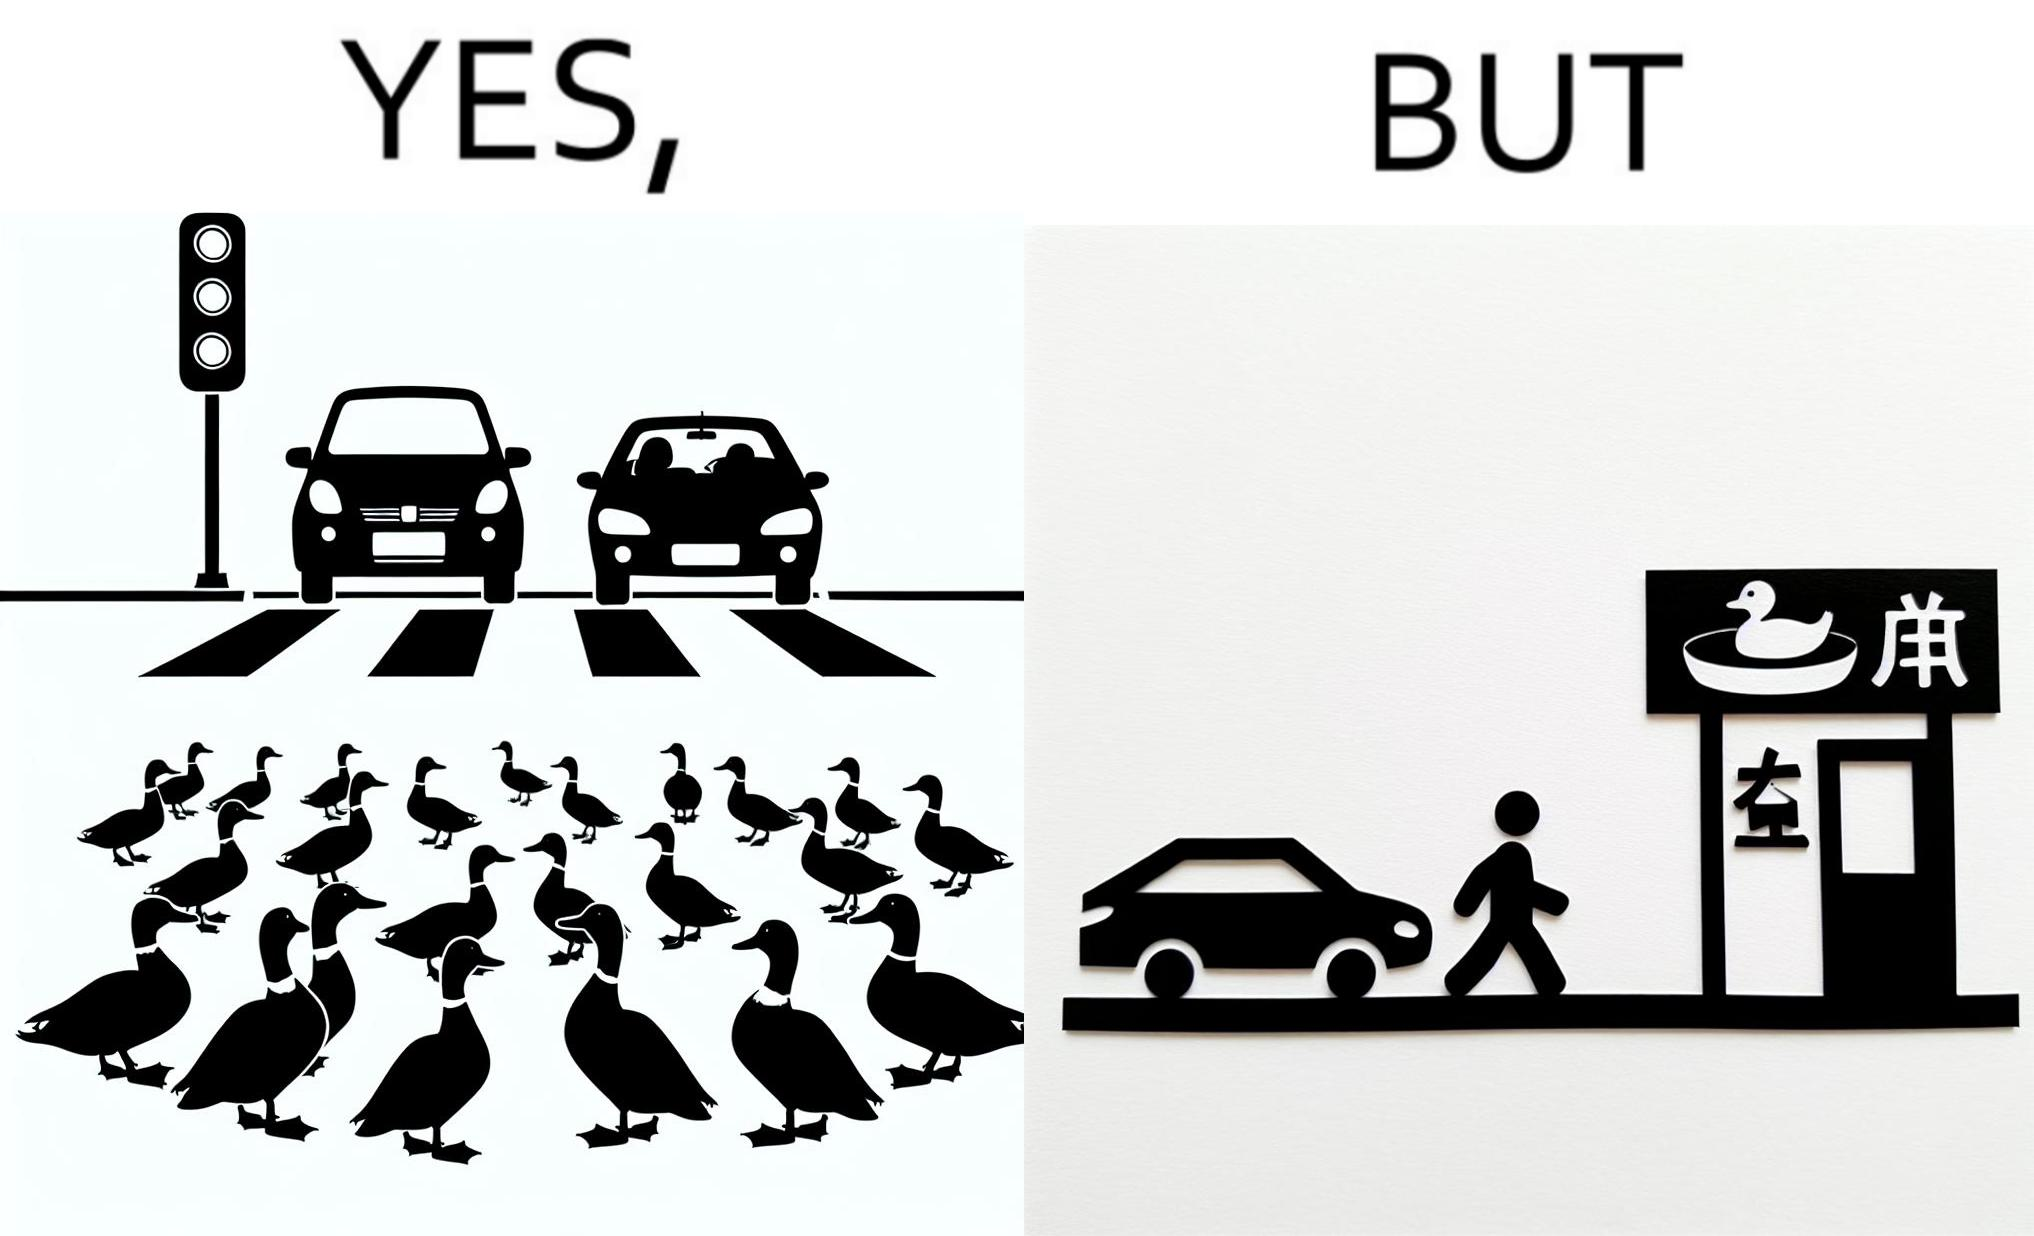Describe the contrast between the left and right parts of this image. In the left part of the image: It is a car stopping to give way to queue of ducks crossing the road and allow them to cross safely In the right part of the image: It is a man parking his car and entering a peking duck shop 